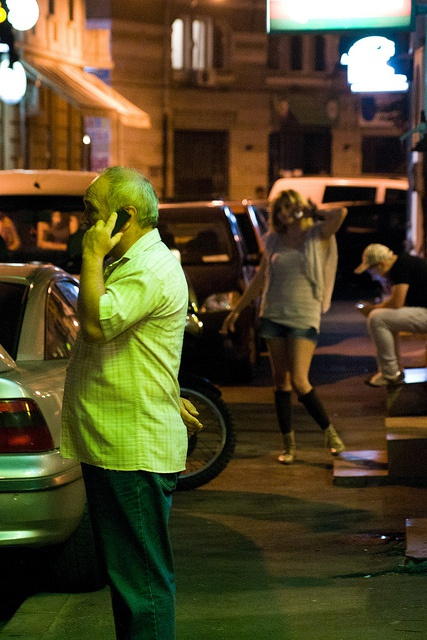Describe the objects in this image and their specific colors. I can see people in black, olive, and lightgreen tones, car in black, olive, maroon, and darkgreen tones, people in black, olive, and maroon tones, car in black, maroon, and brown tones, and truck in black, brown, maroon, and orange tones in this image. 